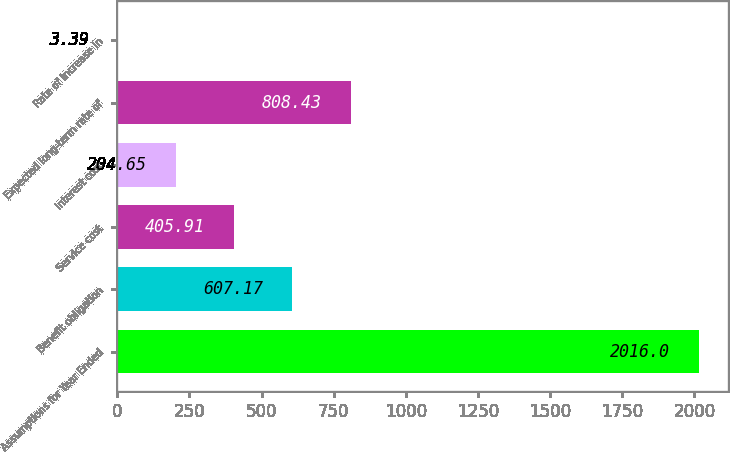Convert chart to OTSL. <chart><loc_0><loc_0><loc_500><loc_500><bar_chart><fcel>Assumptions for Year Ended<fcel>Benefit obligation<fcel>Service cost<fcel>Interest cost<fcel>Expected long-term rate of<fcel>Rate of increase in<nl><fcel>2016<fcel>607.17<fcel>405.91<fcel>204.65<fcel>808.43<fcel>3.39<nl></chart> 